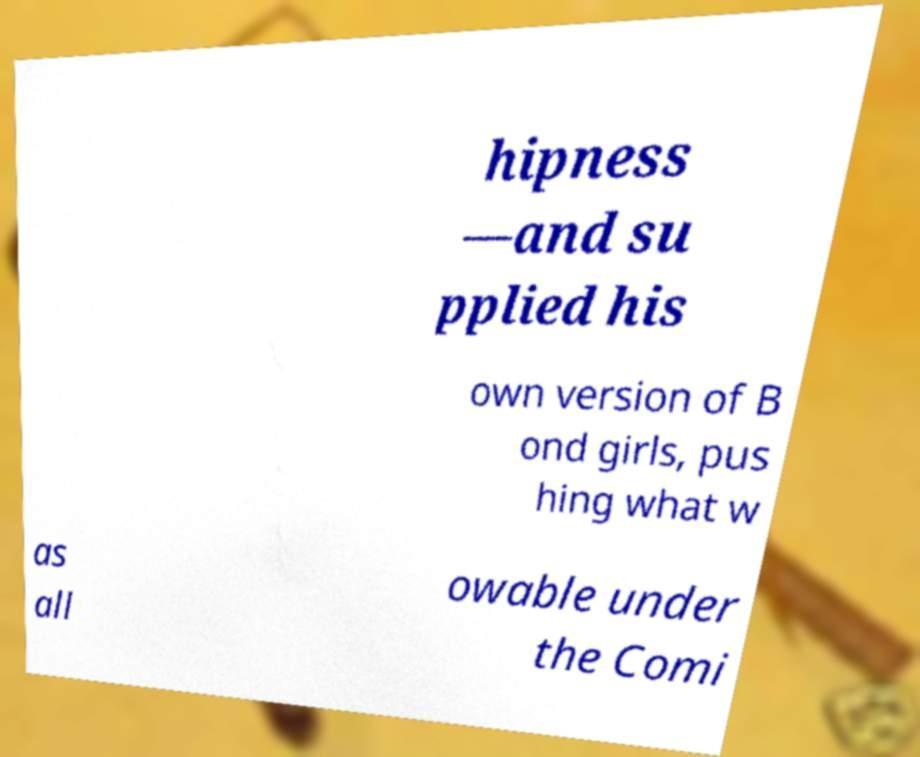Please read and relay the text visible in this image. What does it say? hipness —and su pplied his own version of B ond girls, pus hing what w as all owable under the Comi 